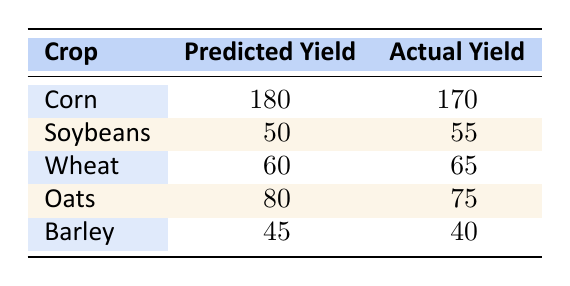What is the predicted yield for Corn? The table indicates that the predicted yield for Corn is listed directly under the "Predicted Yield" column corresponding to the crop "Corn."
Answer: 180 What is the actual yield for Soybeans? The actual yield for Soybeans can be found in the table, where it lines up with the row for "Soybeans" in the "Actual Yield" column.
Answer: 55 Which crop had the highest predicted yield? By comparing the predicted yields for each crop listed in the table, we identify that Corn has the highest predicted yield of 180.
Answer: Corn Is the actual yield for Barley higher than the predicted yield? Checking the values in the table for Barley, the actual yield is 40, while the predicted yield is 45. Since 40 is less than 45, we can confirm the actual yield is not higher.
Answer: No What is the difference between the predicted yield and actual yield for Oats? The predicted yield for Oats is 80 and the actual yield is 75. To find the difference, we subtract the actual yield from the predicted yield: 80 - 75 = 5.
Answer: 5 How many crops have an actual yield that is lower than the predicted yield? Reviewing the table, we check each crop's actual yield against its predicted yield. Corn (170 < 180), and Barley (40 < 45) have lower actual yields. Thus, 2 crops fit this criterion.
Answer: 2 What is the average of the actual yields across all crops? To calculate the average, we first sum the actual yields: 170 + 55 + 65 + 75 + 40 = 405. There are 5 crops, so we divide 405 by 5, which gives us an average of 81.
Answer: 81 Which crop showed the largest discrepancy between the predicted and actual yield? We evaluate the discrepancies for each crop: Corn (10), Soybeans (5), Wheat (5), Oats (5), Barley (5). The largest discrepancy is for Corn with 10.
Answer: Corn 